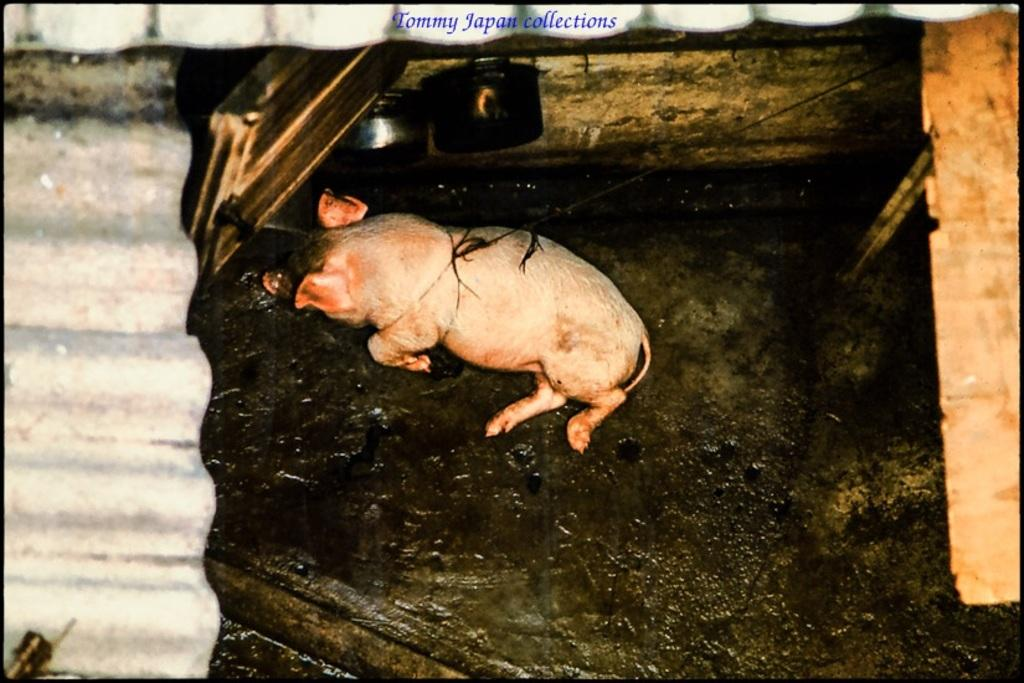What animal is present in the image? There is a pig in the image. How is the pig secured or restrained in the image? The pig is tied with a rope. What type of sweater is the pig wearing in the image? There is no sweater present on the pig in the image. How many rabbits are visible with the pig in the image? There are no rabbits present in the image; only the pig is visible. 